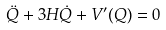<formula> <loc_0><loc_0><loc_500><loc_500>\ddot { Q } + 3 H \dot { Q } + V ^ { \prime } ( Q ) = 0</formula> 